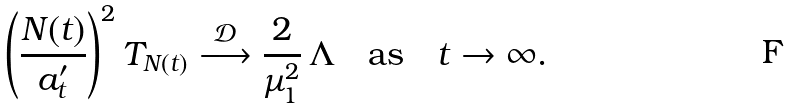<formula> <loc_0><loc_0><loc_500><loc_500>\left ( \frac { N ( t ) } { a ^ { \prime } _ { t } } \right ) ^ { 2 } T _ { N ( t ) } \stackrel { \mathcal { D } } { \longrightarrow } \frac { 2 } { \mu _ { 1 } ^ { 2 } } \, \Lambda \quad \text {as} \quad t \rightarrow \infty .</formula> 